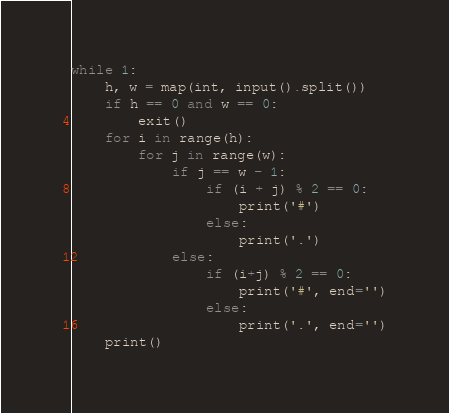<code> <loc_0><loc_0><loc_500><loc_500><_Python_>while 1:
    h, w = map(int, input().split())
    if h == 0 and w == 0:
        exit()
    for i in range(h):
        for j in range(w):
            if j == w - 1:
                if (i + j) % 2 == 0:
                    print('#')
                else:
                    print('.')
            else:
                if (i+j) % 2 == 0:
                    print('#', end='')
                else:
                    print('.', end='')
    print()

</code> 